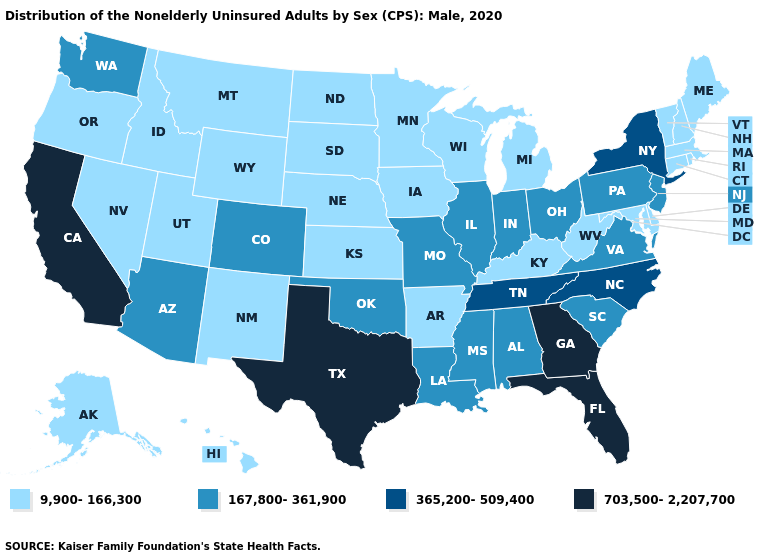Does Nevada have the lowest value in the USA?
Concise answer only. Yes. Among the states that border Kentucky , does West Virginia have the highest value?
Give a very brief answer. No. What is the value of Tennessee?
Quick response, please. 365,200-509,400. Name the states that have a value in the range 167,800-361,900?
Give a very brief answer. Alabama, Arizona, Colorado, Illinois, Indiana, Louisiana, Mississippi, Missouri, New Jersey, Ohio, Oklahoma, Pennsylvania, South Carolina, Virginia, Washington. What is the highest value in the USA?
Concise answer only. 703,500-2,207,700. What is the lowest value in the MidWest?
Be succinct. 9,900-166,300. Does the first symbol in the legend represent the smallest category?
Short answer required. Yes. Which states hav the highest value in the Northeast?
Answer briefly. New York. Name the states that have a value in the range 9,900-166,300?
Concise answer only. Alaska, Arkansas, Connecticut, Delaware, Hawaii, Idaho, Iowa, Kansas, Kentucky, Maine, Maryland, Massachusetts, Michigan, Minnesota, Montana, Nebraska, Nevada, New Hampshire, New Mexico, North Dakota, Oregon, Rhode Island, South Dakota, Utah, Vermont, West Virginia, Wisconsin, Wyoming. Does Georgia have the highest value in the USA?
Write a very short answer. Yes. Among the states that border Ohio , does Pennsylvania have the lowest value?
Answer briefly. No. Is the legend a continuous bar?
Keep it brief. No. Does New York have the highest value in the Northeast?
Write a very short answer. Yes. Among the states that border Colorado , does Oklahoma have the highest value?
Be succinct. Yes. Does Wyoming have the same value as Pennsylvania?
Give a very brief answer. No. 